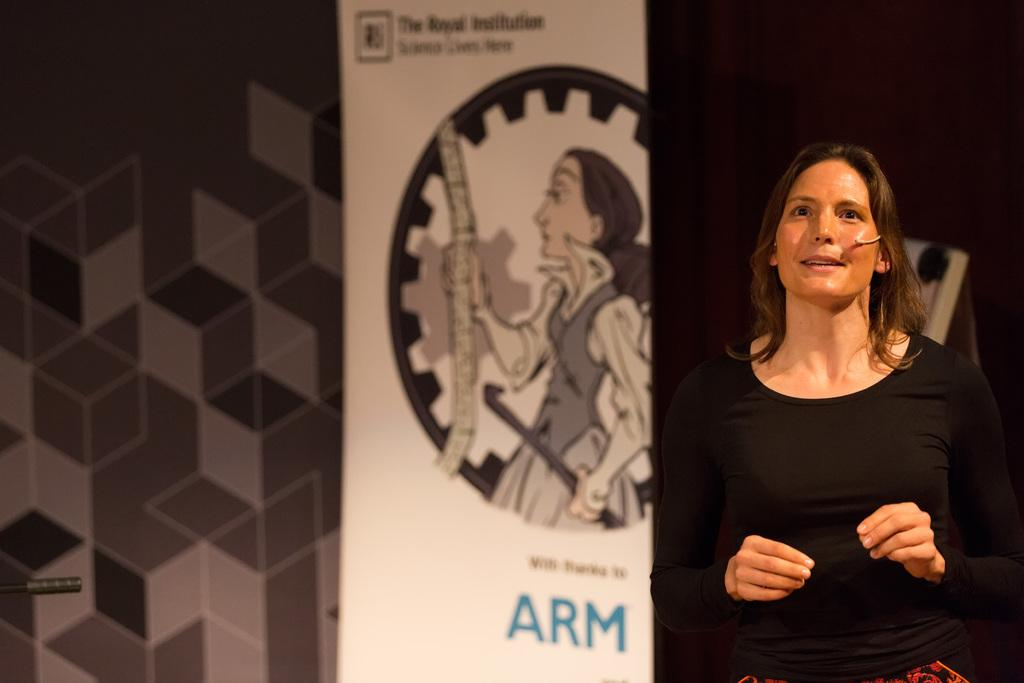Who is the main subject in the picture? There is a girl in the picture. What is the girl wearing? The girl is wearing a black t-shirt. Where is the girl located in the image? The girl is standing on a stage. What is the girl doing on the stage? The girl is giving a speech. What can be seen in the background of the image? There is a white color art design banner in the background. What news is the girl reading from the letters on the stage? There is no news or letters present in the image; the girl is giving a speech. 